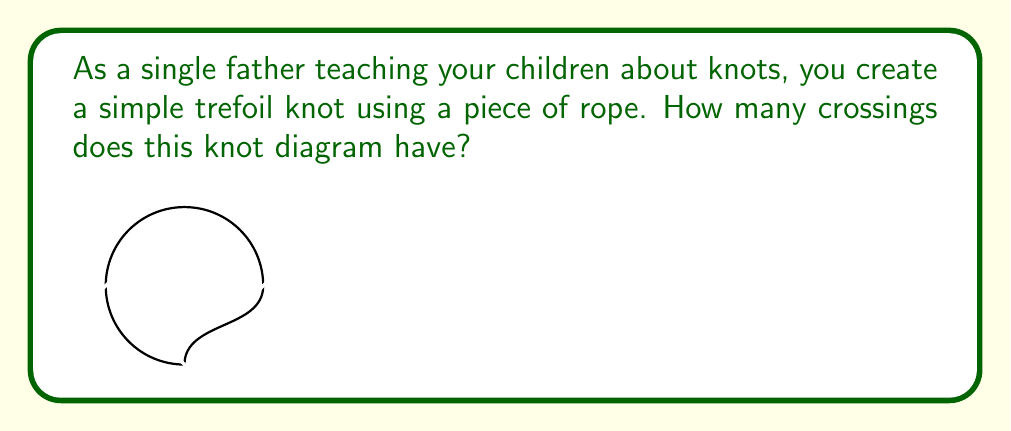Can you answer this question? To determine the crossing number of a simple knot diagram, we need to count the number of times the rope crosses over itself in the diagram. Let's analyze the trefoil knot step-by-step:

1. Start at any point on the knot and follow the rope's path.

2. Count each instance where the rope passes over or under itself:
   a. First crossing: The rope goes under at the bottom.
   b. Second crossing: The rope goes over at the top right.
   c. Third crossing: The rope goes over at the top left.

3. After completing the circuit, we've counted all the crossings.

The crossing number is defined as the minimum number of crossings in any diagram of the knot. For the trefoil knot, this minimum is achieved in the given diagram.

Therefore, the crossing number of this simple trefoil knot diagram is 3.
Answer: 3 